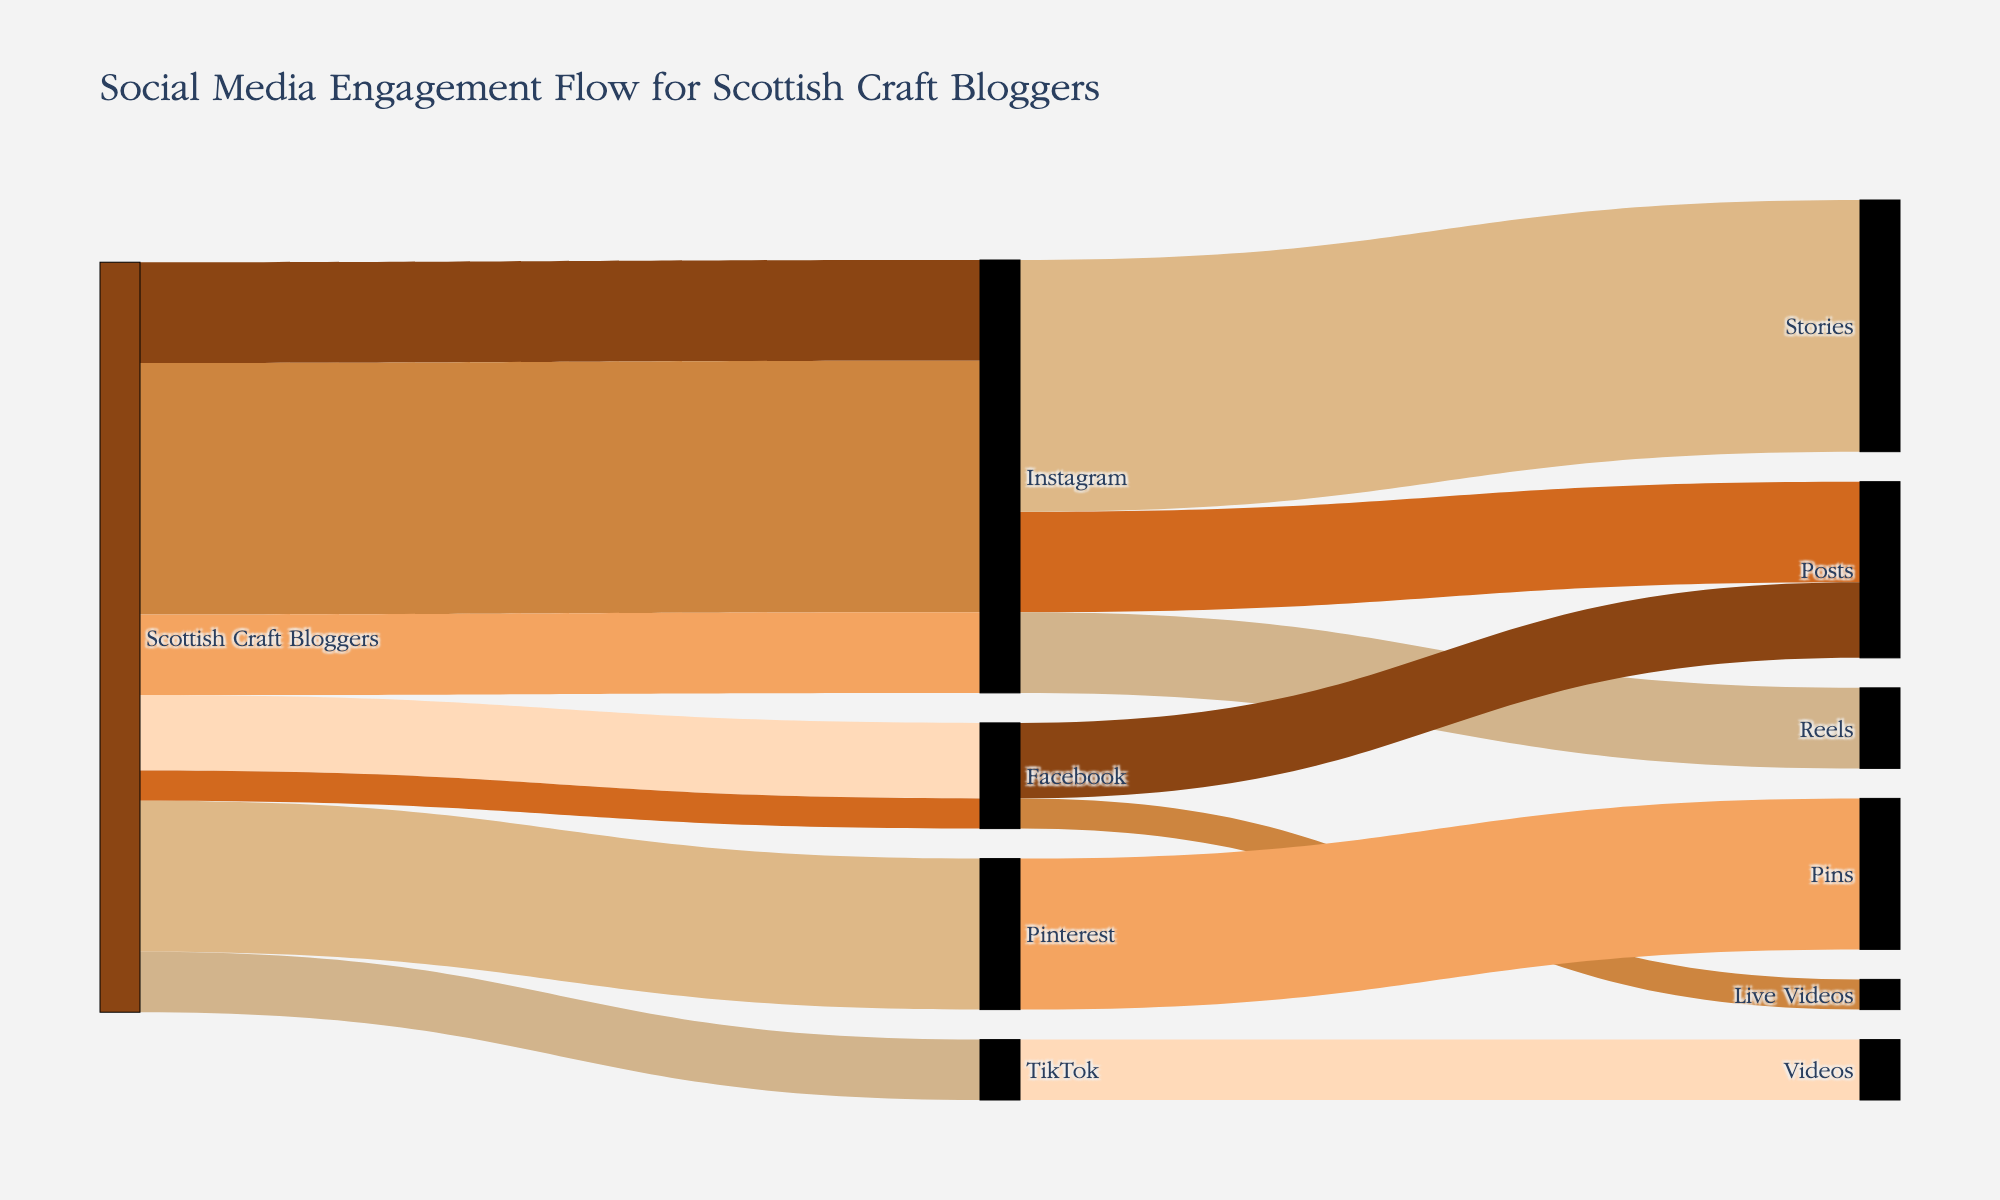Which platform do Scottish Craft Bloggers use the most for posts? Look at the flow from Scottish Craft Bloggers to each platform and identify the flow with the highest count towards "Posts".
Answer: Instagram How many total engagement items do Scottish Craft Bloggers produce on Instagram? Sum the counts of all types of engagements (Posts, Stories, and Reels) on Instagram. 1000 + 2500 + 800 = 4300
Answer: 4300 Which engagement type on Facebook has a higher count, Posts or Live Videos? Compare the counts between Facebook Posts (750) and Facebook Live Videos (300).
Answer: Posts What is the total number of engagement items produced across all platforms? Add the counts of all engagement items from the diagram. 
1000 (Instagram Posts) + 2500 (Instagram Stories) + 800 (Instagram Reels) + 750 (Facebook Posts) + 300 (Facebook Live Videos) + 1500 (Pins on Pinterest) + 600 (TikTok Videos) = 7450
Answer: 7450 Which social media platform has the fewest distinct types of engagement metrics tracked? Count the distinct engagement types for each platform: Instagram (Posts, Stories, Reels), Facebook (Posts, Live Videos), Pinterest (Pins), TikTok (Videos). Pinterest and TikTok both have only one engagement metric.
Answer: Pinterest and TikTok How does the engagement count for Facebook Posts compare to TikTok Videos? Compare the counts for Facebook Posts (750) and TikTok Videos (600) directly to see which is higher.
Answer: Facebook Posts are higher What's the predominant type of engagement for Pinterest? Look at the engagement metric associated with Pinterest, which is Pins, and its count (1500).
Answer: Pins Which platform is most diversified in terms of engagement types? Evaluate the number of engagement types for each platform: Instagram (3 types), Facebook (2 types), Pinterest (1 type), TikTok (1 type). Instagram has the most engagement types tracked.
Answer: Instagram 